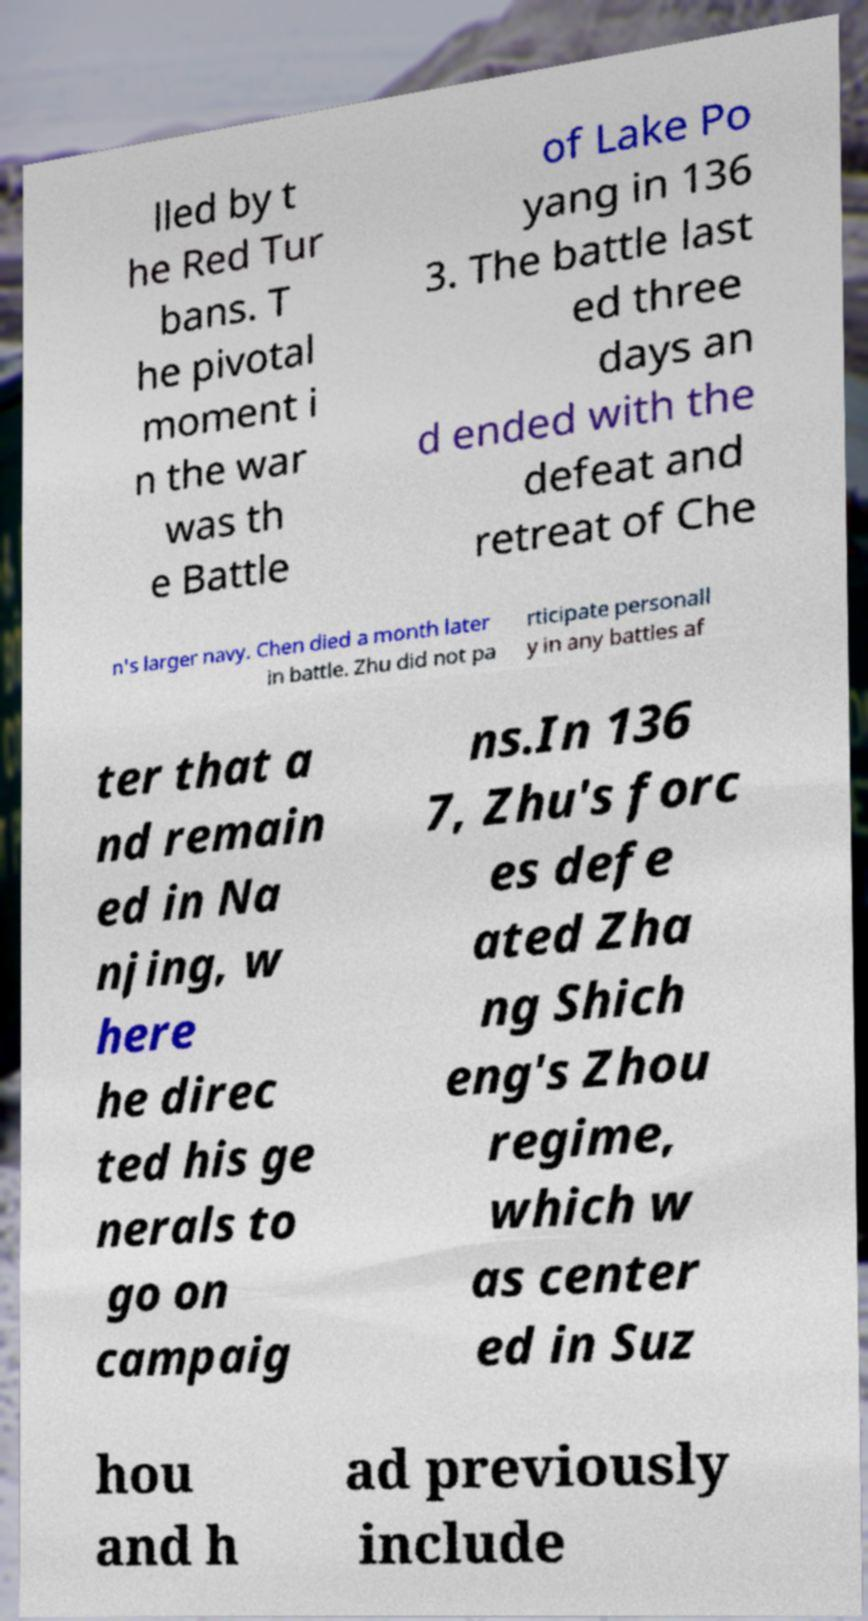Could you extract and type out the text from this image? lled by t he Red Tur bans. T he pivotal moment i n the war was th e Battle of Lake Po yang in 136 3. The battle last ed three days an d ended with the defeat and retreat of Che n's larger navy. Chen died a month later in battle. Zhu did not pa rticipate personall y in any battles af ter that a nd remain ed in Na njing, w here he direc ted his ge nerals to go on campaig ns.In 136 7, Zhu's forc es defe ated Zha ng Shich eng's Zhou regime, which w as center ed in Suz hou and h ad previously include 